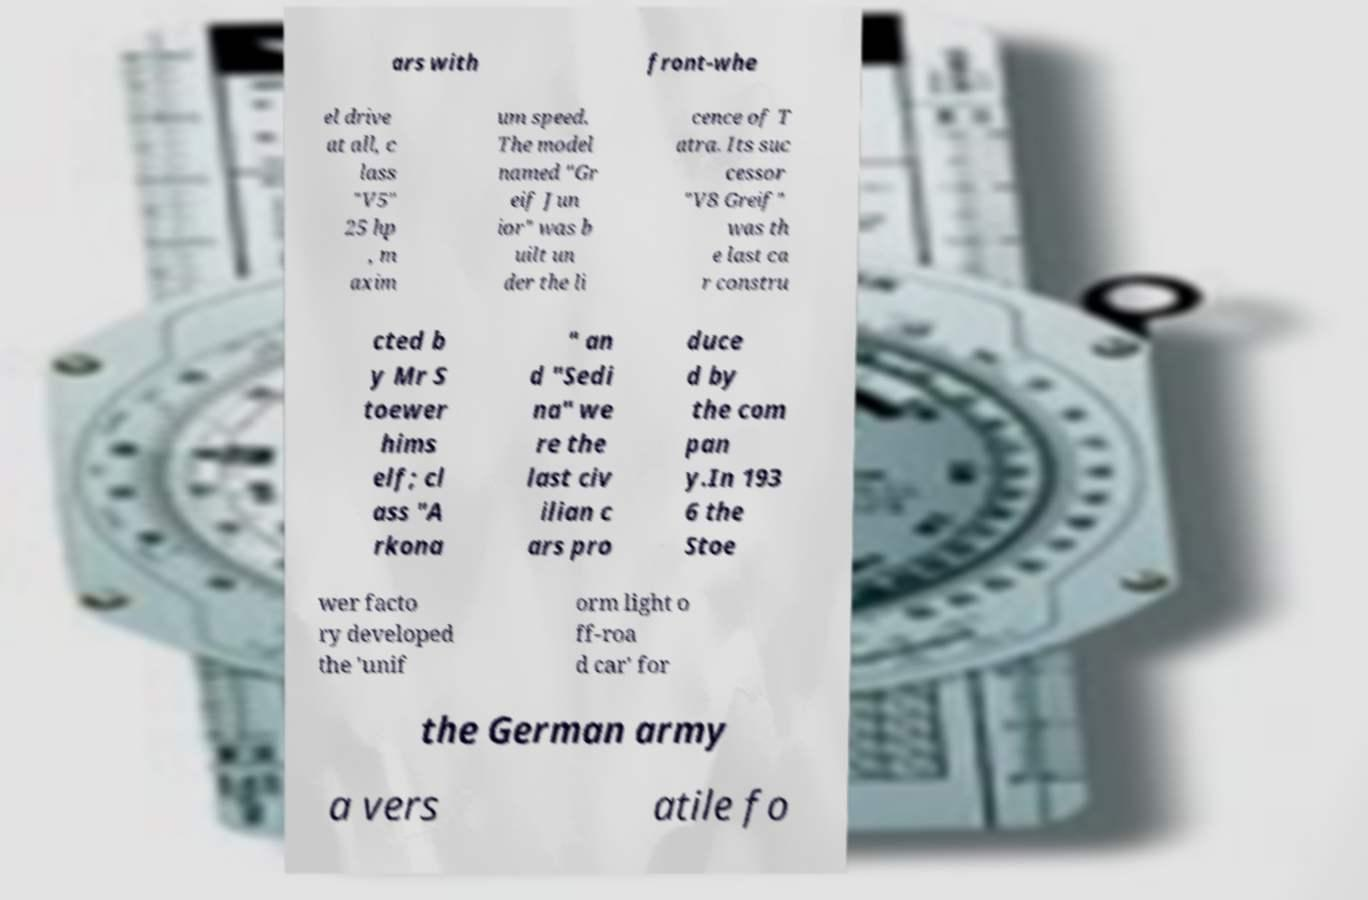There's text embedded in this image that I need extracted. Can you transcribe it verbatim? ars with front-whe el drive at all, c lass "V5" 25 hp , m axim um speed. The model named "Gr eif Jun ior" was b uilt un der the li cence of T atra. Its suc cessor "V8 Greif" was th e last ca r constru cted b y Mr S toewer hims elf; cl ass "A rkona " an d "Sedi na" we re the last civ ilian c ars pro duce d by the com pan y.In 193 6 the Stoe wer facto ry developed the 'unif orm light o ff-roa d car' for the German army a vers atile fo 